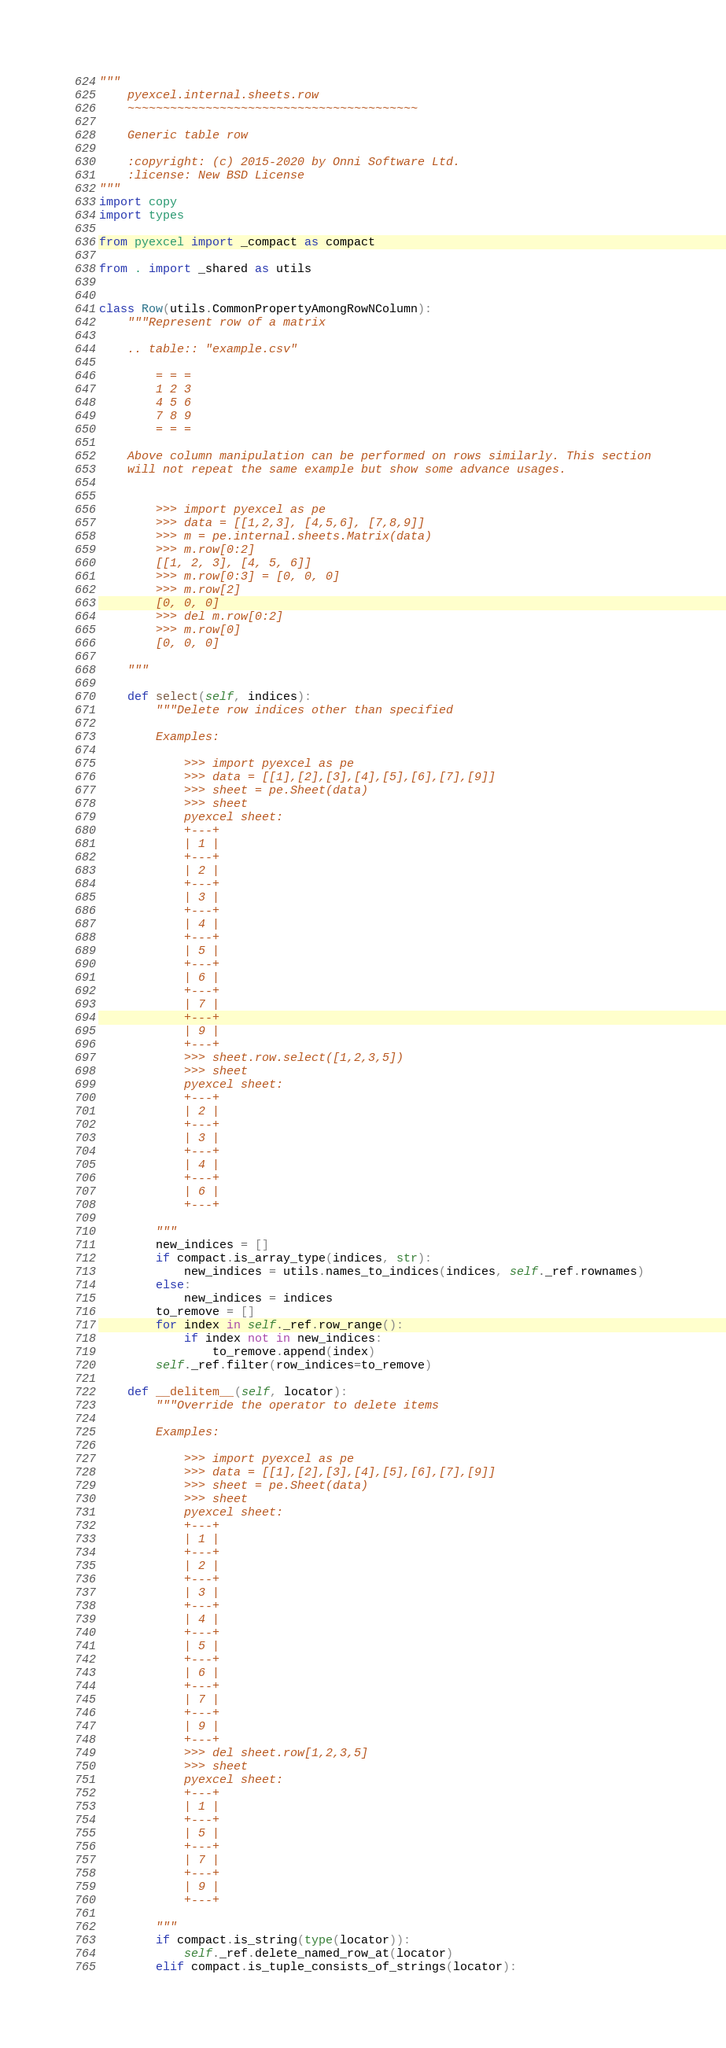<code> <loc_0><loc_0><loc_500><loc_500><_Python_>"""
    pyexcel.internal.sheets.row
    ~~~~~~~~~~~~~~~~~~~~~~~~~~~~~~~~~~~~~~~~~

    Generic table row

    :copyright: (c) 2015-2020 by Onni Software Ltd.
    :license: New BSD License
"""
import copy
import types

from pyexcel import _compact as compact

from . import _shared as utils


class Row(utils.CommonPropertyAmongRowNColumn):
    """Represent row of a matrix

    .. table:: "example.csv"

        = = =
        1 2 3
        4 5 6
        7 8 9
        = = =

    Above column manipulation can be performed on rows similarly. This section
    will not repeat the same example but show some advance usages.


        >>> import pyexcel as pe
        >>> data = [[1,2,3], [4,5,6], [7,8,9]]
        >>> m = pe.internal.sheets.Matrix(data)
        >>> m.row[0:2]
        [[1, 2, 3], [4, 5, 6]]
        >>> m.row[0:3] = [0, 0, 0]
        >>> m.row[2]
        [0, 0, 0]
        >>> del m.row[0:2]
        >>> m.row[0]
        [0, 0, 0]

    """

    def select(self, indices):
        """Delete row indices other than specified

        Examples:

            >>> import pyexcel as pe
            >>> data = [[1],[2],[3],[4],[5],[6],[7],[9]]
            >>> sheet = pe.Sheet(data)
            >>> sheet
            pyexcel sheet:
            +---+
            | 1 |
            +---+
            | 2 |
            +---+
            | 3 |
            +---+
            | 4 |
            +---+
            | 5 |
            +---+
            | 6 |
            +---+
            | 7 |
            +---+
            | 9 |
            +---+
            >>> sheet.row.select([1,2,3,5])
            >>> sheet
            pyexcel sheet:
            +---+
            | 2 |
            +---+
            | 3 |
            +---+
            | 4 |
            +---+
            | 6 |
            +---+

        """
        new_indices = []
        if compact.is_array_type(indices, str):
            new_indices = utils.names_to_indices(indices, self._ref.rownames)
        else:
            new_indices = indices
        to_remove = []
        for index in self._ref.row_range():
            if index not in new_indices:
                to_remove.append(index)
        self._ref.filter(row_indices=to_remove)

    def __delitem__(self, locator):
        """Override the operator to delete items

        Examples:

            >>> import pyexcel as pe
            >>> data = [[1],[2],[3],[4],[5],[6],[7],[9]]
            >>> sheet = pe.Sheet(data)
            >>> sheet
            pyexcel sheet:
            +---+
            | 1 |
            +---+
            | 2 |
            +---+
            | 3 |
            +---+
            | 4 |
            +---+
            | 5 |
            +---+
            | 6 |
            +---+
            | 7 |
            +---+
            | 9 |
            +---+
            >>> del sheet.row[1,2,3,5]
            >>> sheet
            pyexcel sheet:
            +---+
            | 1 |
            +---+
            | 5 |
            +---+
            | 7 |
            +---+
            | 9 |
            +---+

        """
        if compact.is_string(type(locator)):
            self._ref.delete_named_row_at(locator)
        elif compact.is_tuple_consists_of_strings(locator):</code> 